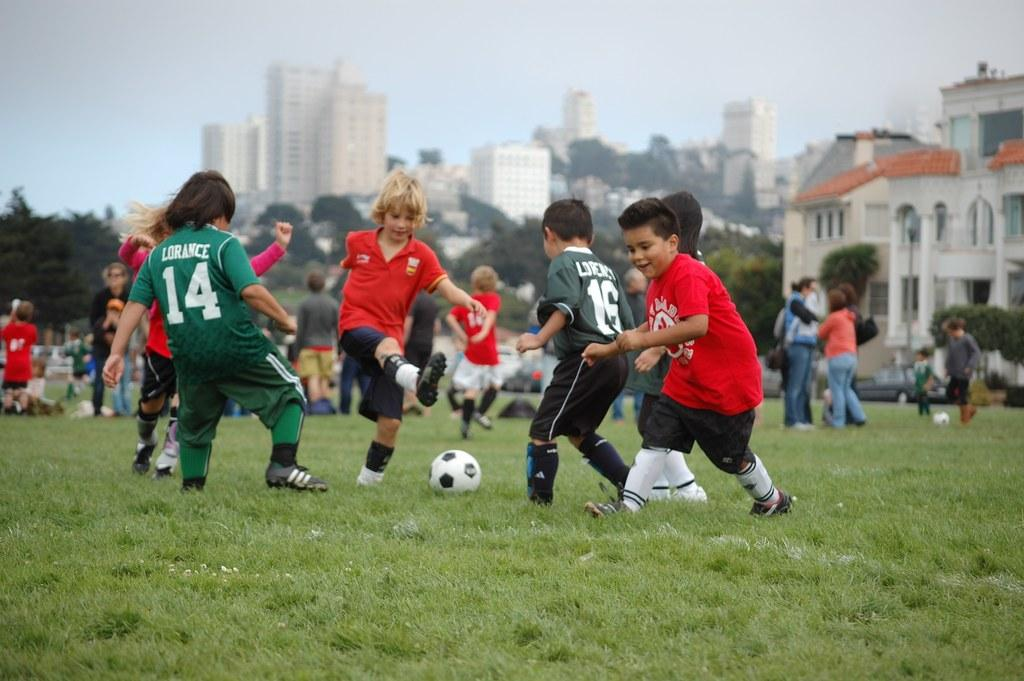<image>
Describe the image concisely. Two kids with jerseys that say Lorance play soccer with others. 